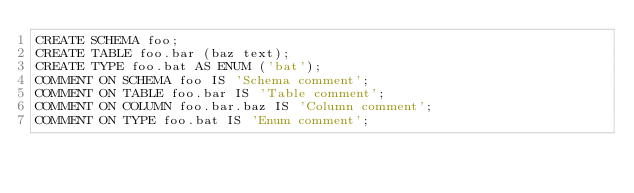<code> <loc_0><loc_0><loc_500><loc_500><_SQL_>CREATE SCHEMA foo;
CREATE TABLE foo.bar (baz text);
CREATE TYPE foo.bat AS ENUM ('bat');
COMMENT ON SCHEMA foo IS 'Schema comment';
COMMENT ON TABLE foo.bar IS 'Table comment';
COMMENT ON COLUMN foo.bar.baz IS 'Column comment';
COMMENT ON TYPE foo.bat IS 'Enum comment';</code> 